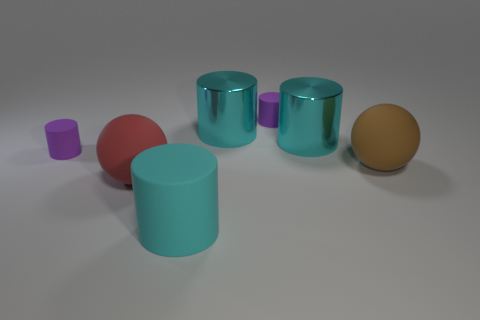Subtract all cyan cylinders. How many were subtracted if there are1cyan cylinders left? 2 Subtract all gray spheres. How many cyan cylinders are left? 3 Subtract all big matte cylinders. How many cylinders are left? 4 Subtract 1 cylinders. How many cylinders are left? 4 Subtract all red cylinders. Subtract all blue balls. How many cylinders are left? 5 Add 3 tiny things. How many objects exist? 10 Subtract all balls. How many objects are left? 5 Add 2 blue cylinders. How many blue cylinders exist? 2 Subtract 2 purple cylinders. How many objects are left? 5 Subtract all small rubber objects. Subtract all big cyan matte cylinders. How many objects are left? 4 